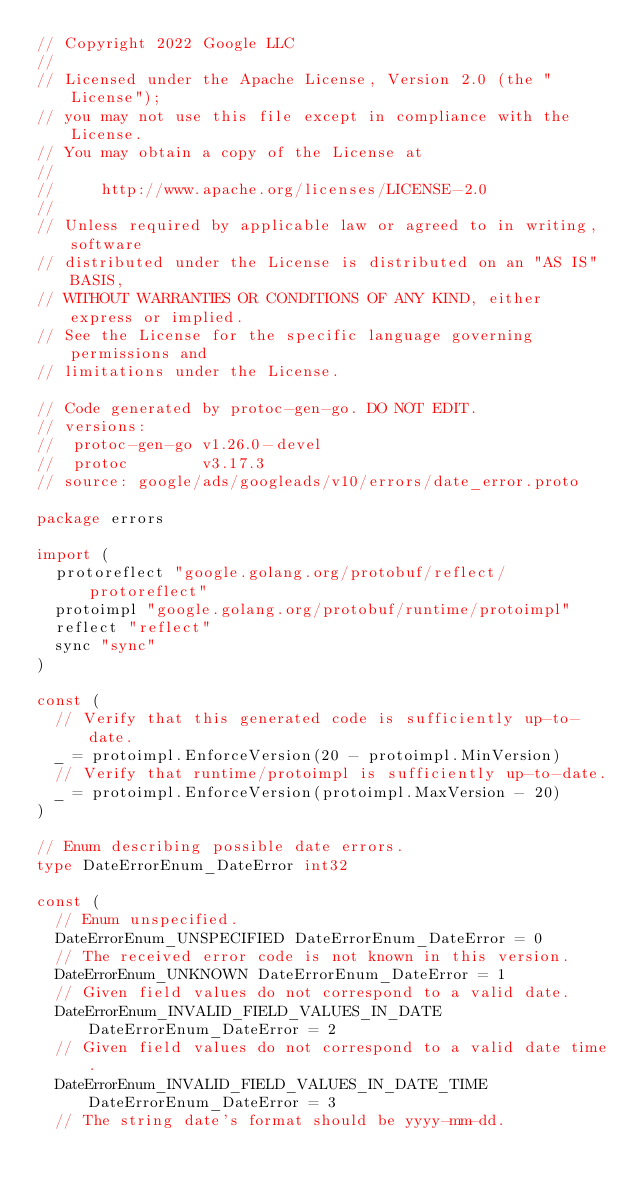Convert code to text. <code><loc_0><loc_0><loc_500><loc_500><_Go_>// Copyright 2022 Google LLC
//
// Licensed under the Apache License, Version 2.0 (the "License");
// you may not use this file except in compliance with the License.
// You may obtain a copy of the License at
//
//     http://www.apache.org/licenses/LICENSE-2.0
//
// Unless required by applicable law or agreed to in writing, software
// distributed under the License is distributed on an "AS IS" BASIS,
// WITHOUT WARRANTIES OR CONDITIONS OF ANY KIND, either express or implied.
// See the License for the specific language governing permissions and
// limitations under the License.

// Code generated by protoc-gen-go. DO NOT EDIT.
// versions:
// 	protoc-gen-go v1.26.0-devel
// 	protoc        v3.17.3
// source: google/ads/googleads/v10/errors/date_error.proto

package errors

import (
	protoreflect "google.golang.org/protobuf/reflect/protoreflect"
	protoimpl "google.golang.org/protobuf/runtime/protoimpl"
	reflect "reflect"
	sync "sync"
)

const (
	// Verify that this generated code is sufficiently up-to-date.
	_ = protoimpl.EnforceVersion(20 - protoimpl.MinVersion)
	// Verify that runtime/protoimpl is sufficiently up-to-date.
	_ = protoimpl.EnforceVersion(protoimpl.MaxVersion - 20)
)

// Enum describing possible date errors.
type DateErrorEnum_DateError int32

const (
	// Enum unspecified.
	DateErrorEnum_UNSPECIFIED DateErrorEnum_DateError = 0
	// The received error code is not known in this version.
	DateErrorEnum_UNKNOWN DateErrorEnum_DateError = 1
	// Given field values do not correspond to a valid date.
	DateErrorEnum_INVALID_FIELD_VALUES_IN_DATE DateErrorEnum_DateError = 2
	// Given field values do not correspond to a valid date time.
	DateErrorEnum_INVALID_FIELD_VALUES_IN_DATE_TIME DateErrorEnum_DateError = 3
	// The string date's format should be yyyy-mm-dd.</code> 